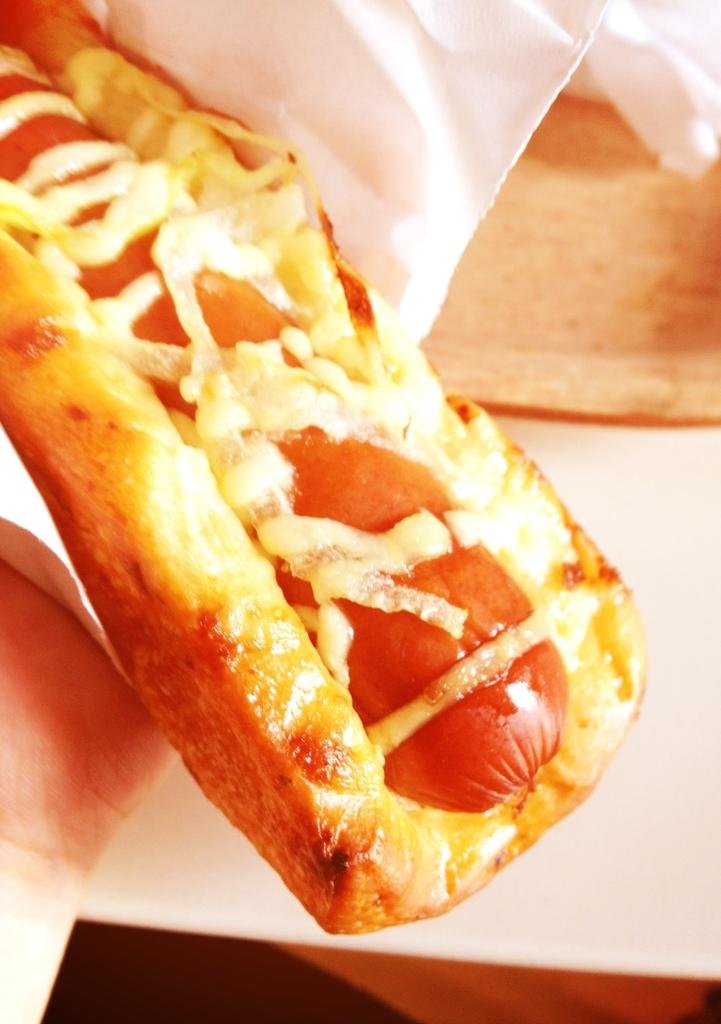What part of a person is visible in the image? There is a hand of a person in the image. What else can be seen in the image besides the hand? There is food and tissue paper visible in the image. Can you describe the food in the image? The provided facts do not specify the type of food in the image. What might be the purpose of the tissue paper in the image? The tissue paper might be used for cleaning or wiping in the image. How many babies are visible in the image? There are no babies present in the image. What achievements has the achiever accomplished in the image? There is no achiever present in the image. What type of relationship does the sister have with the person in the image? There is no sister present in the image. 